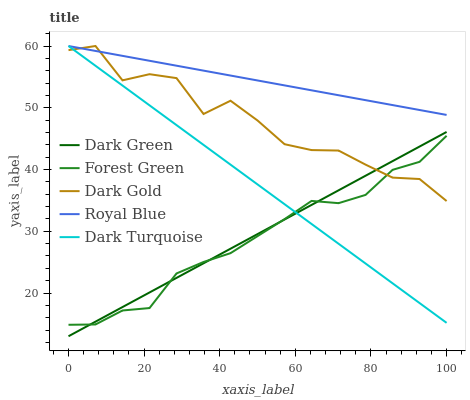Does Forest Green have the minimum area under the curve?
Answer yes or no. Yes. Does Royal Blue have the maximum area under the curve?
Answer yes or no. Yes. Does Dark Gold have the minimum area under the curve?
Answer yes or no. No. Does Dark Gold have the maximum area under the curve?
Answer yes or no. No. Is Dark Green the smoothest?
Answer yes or no. Yes. Is Dark Gold the roughest?
Answer yes or no. Yes. Is Forest Green the smoothest?
Answer yes or no. No. Is Forest Green the roughest?
Answer yes or no. No. Does Forest Green have the lowest value?
Answer yes or no. No. Does Forest Green have the highest value?
Answer yes or no. No. Is Forest Green less than Royal Blue?
Answer yes or no. Yes. Is Royal Blue greater than Dark Green?
Answer yes or no. Yes. Does Forest Green intersect Royal Blue?
Answer yes or no. No. 